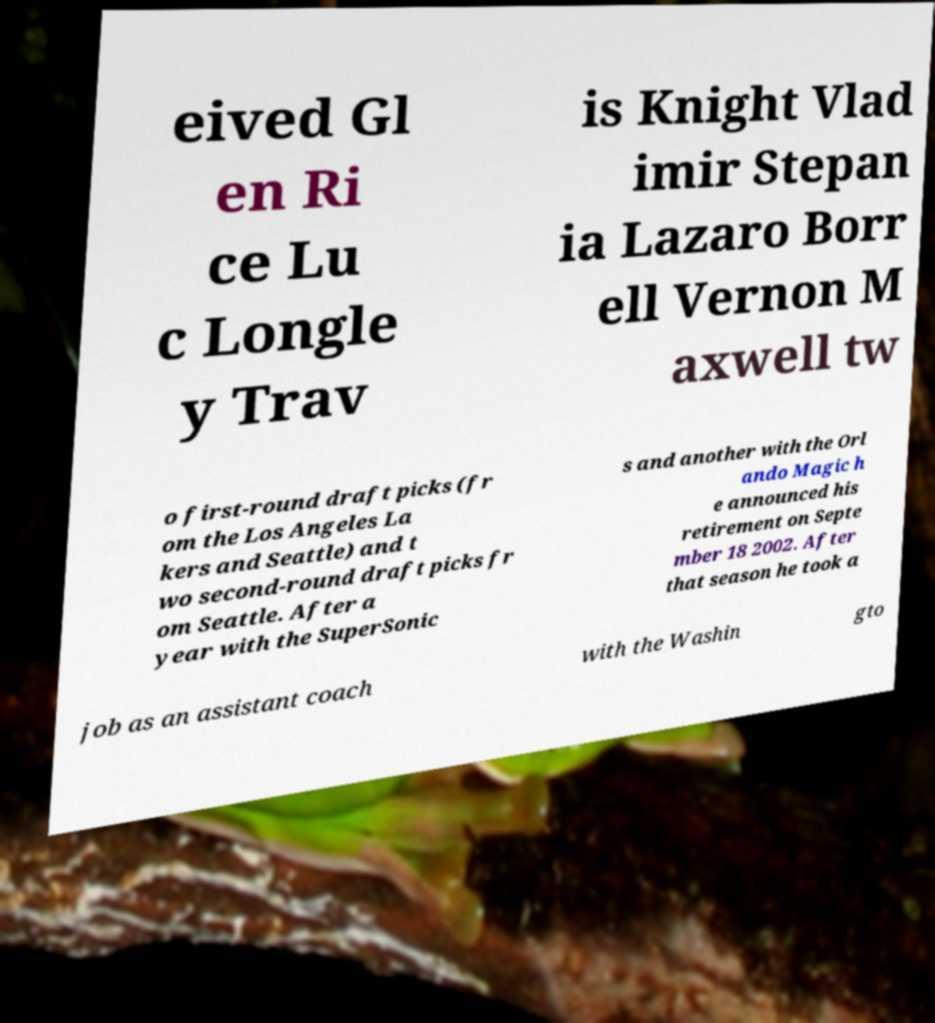What messages or text are displayed in this image? I need them in a readable, typed format. eived Gl en Ri ce Lu c Longle y Trav is Knight Vlad imir Stepan ia Lazaro Borr ell Vernon M axwell tw o first-round draft picks (fr om the Los Angeles La kers and Seattle) and t wo second-round draft picks fr om Seattle. After a year with the SuperSonic s and another with the Orl ando Magic h e announced his retirement on Septe mber 18 2002. After that season he took a job as an assistant coach with the Washin gto 